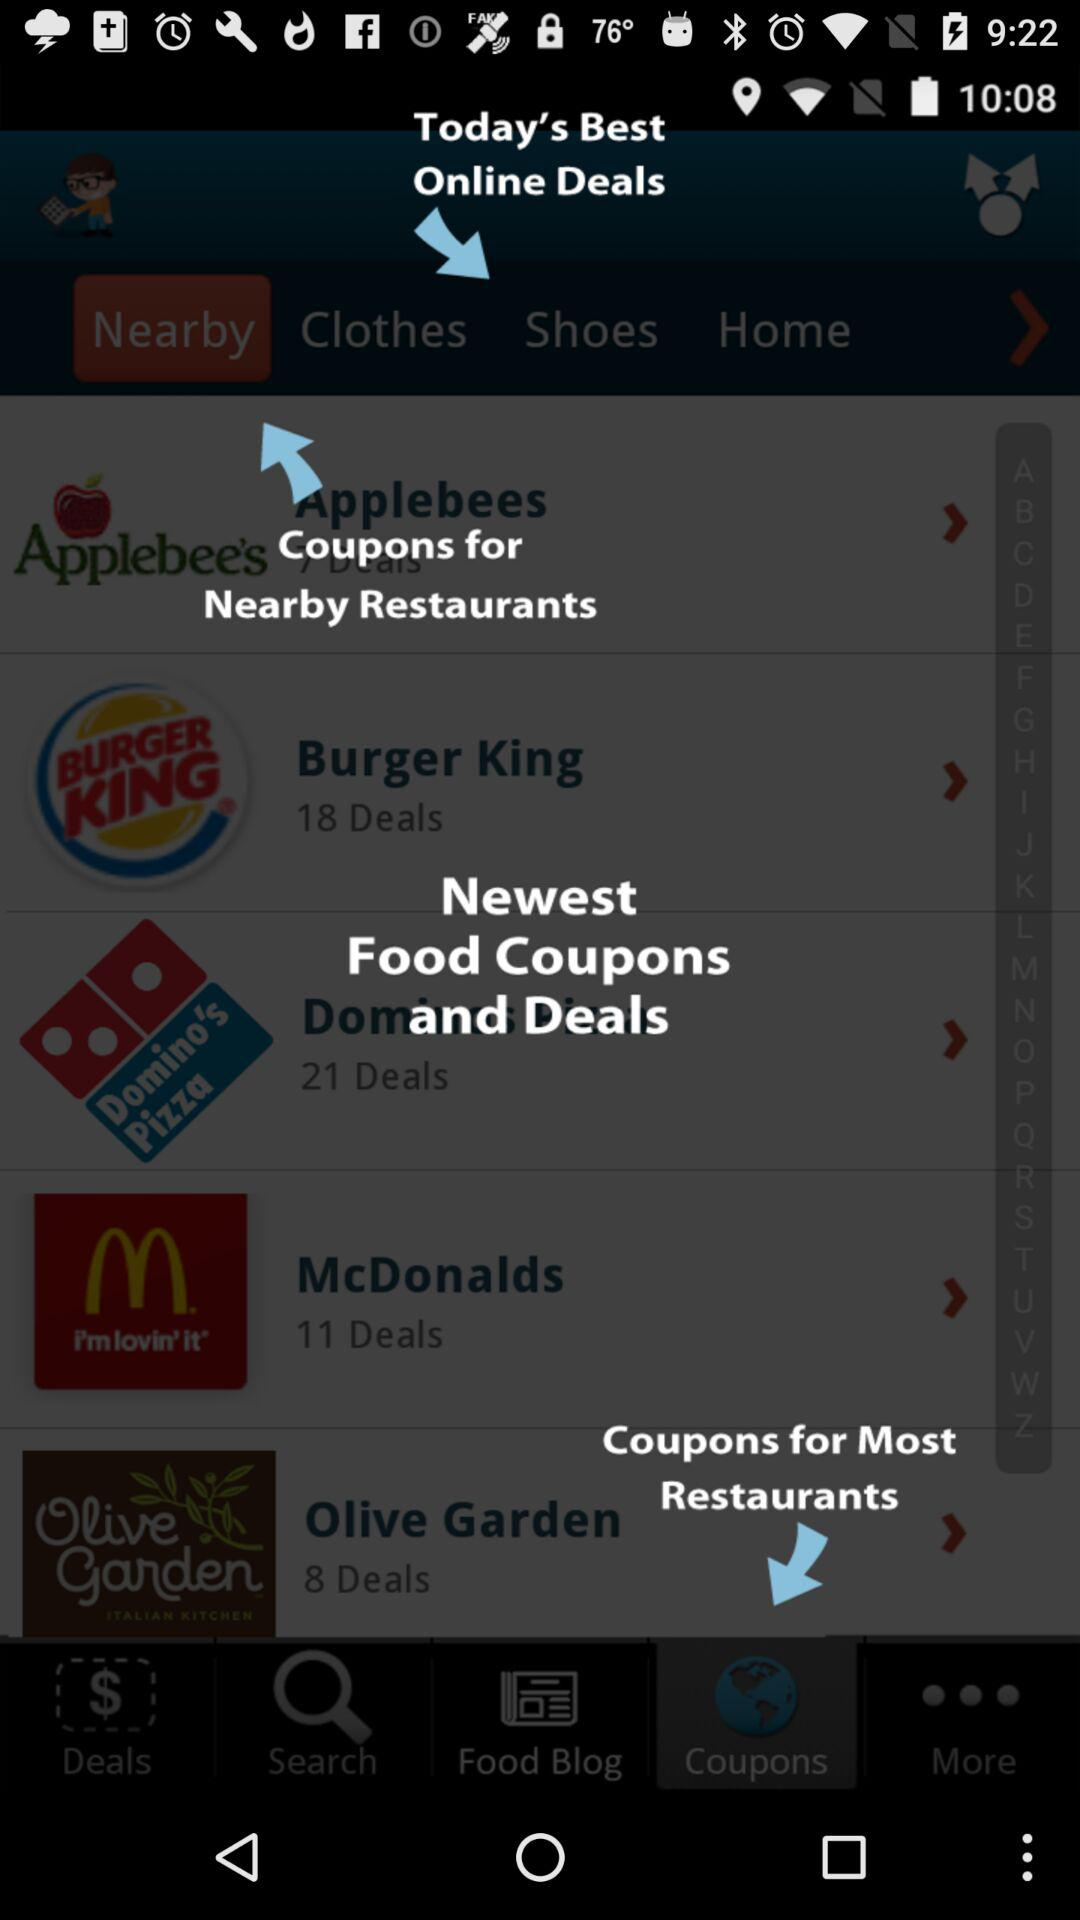How many more deals does Domino's Pizza have than McDonalds?
Answer the question using a single word or phrase. 10 